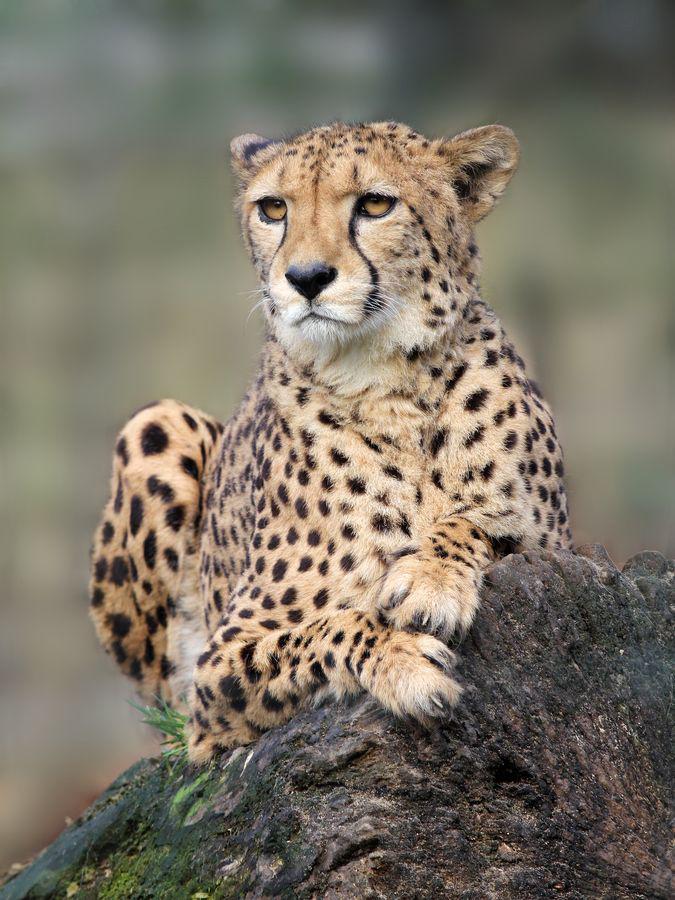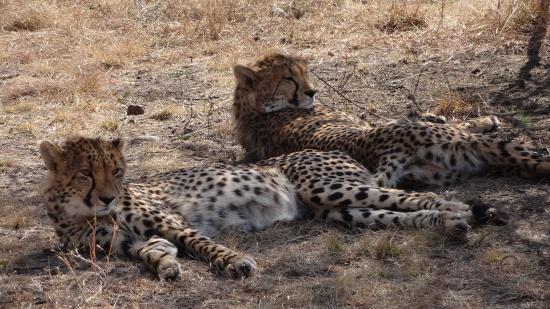The first image is the image on the left, the second image is the image on the right. Analyze the images presented: Is the assertion "The left image contains exactly two cheetahs." valid? Answer yes or no. No. 